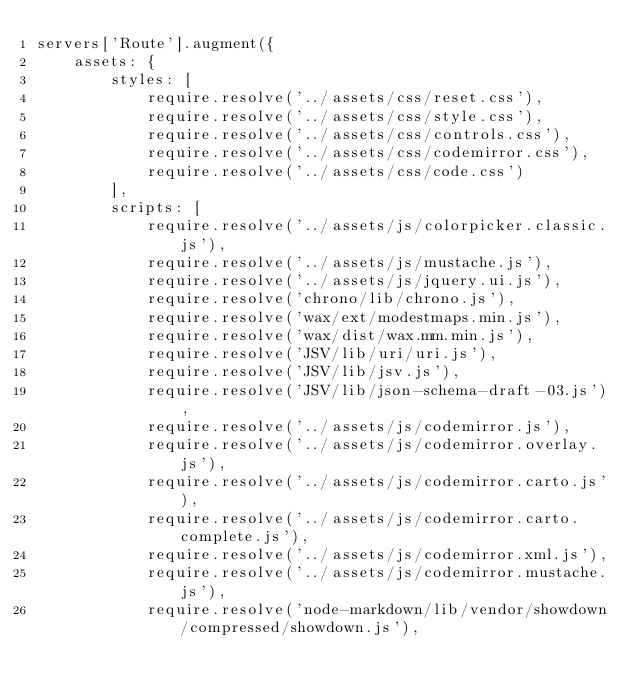Convert code to text. <code><loc_0><loc_0><loc_500><loc_500><_JavaScript_>servers['Route'].augment({
    assets: {
        styles: [
            require.resolve('../assets/css/reset.css'),
            require.resolve('../assets/css/style.css'),
            require.resolve('../assets/css/controls.css'),
            require.resolve('../assets/css/codemirror.css'),
            require.resolve('../assets/css/code.css')
        ],
        scripts: [
            require.resolve('../assets/js/colorpicker.classic.js'),
            require.resolve('../assets/js/mustache.js'),
            require.resolve('../assets/js/jquery.ui.js'),
            require.resolve('chrono/lib/chrono.js'),
            require.resolve('wax/ext/modestmaps.min.js'),
            require.resolve('wax/dist/wax.mm.min.js'),
            require.resolve('JSV/lib/uri/uri.js'),
            require.resolve('JSV/lib/jsv.js'),
            require.resolve('JSV/lib/json-schema-draft-03.js'),
            require.resolve('../assets/js/codemirror.js'),
            require.resolve('../assets/js/codemirror.overlay.js'),
            require.resolve('../assets/js/codemirror.carto.js'),
            require.resolve('../assets/js/codemirror.carto.complete.js'),
            require.resolve('../assets/js/codemirror.xml.js'),
            require.resolve('../assets/js/codemirror.mustache.js'),
            require.resolve('node-markdown/lib/vendor/showdown/compressed/showdown.js'),</code> 